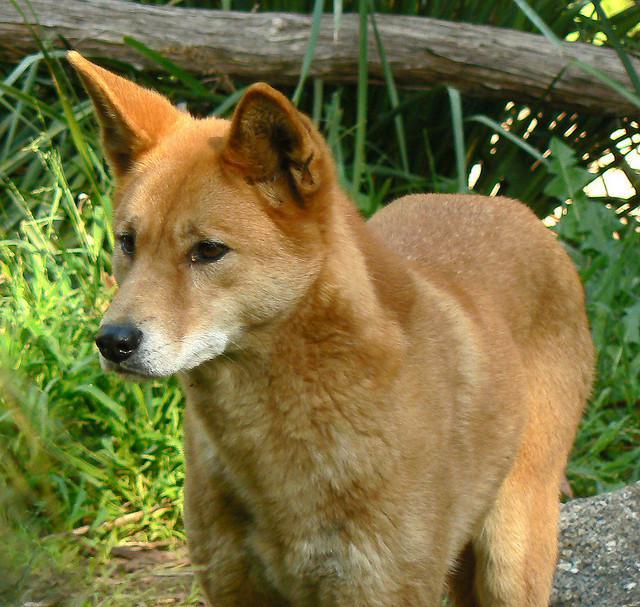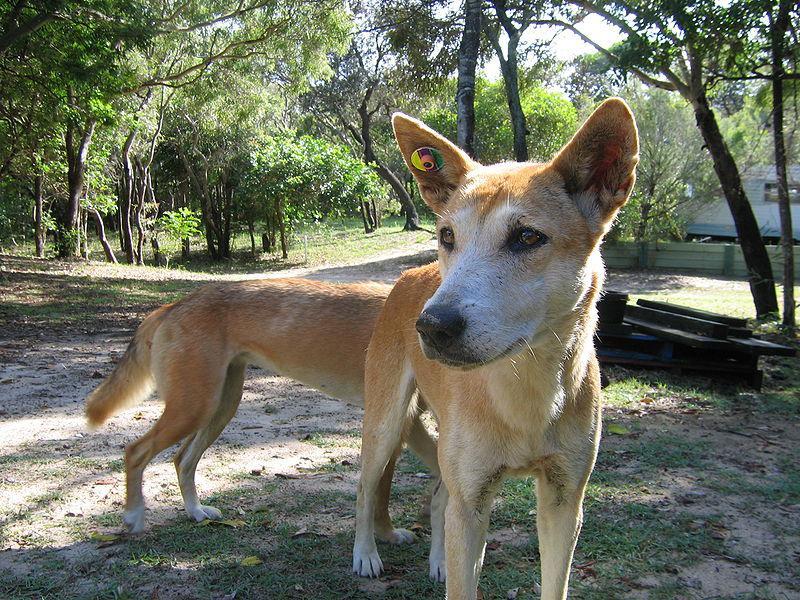The first image is the image on the left, the second image is the image on the right. Assess this claim about the two images: "The combined images contain five dingos, and at least one dingo is reclining.". Correct or not? Answer yes or no. No. The first image is the image on the left, the second image is the image on the right. Examine the images to the left and right. Is the description "There are at most three dingoes." accurate? Answer yes or no. Yes. 